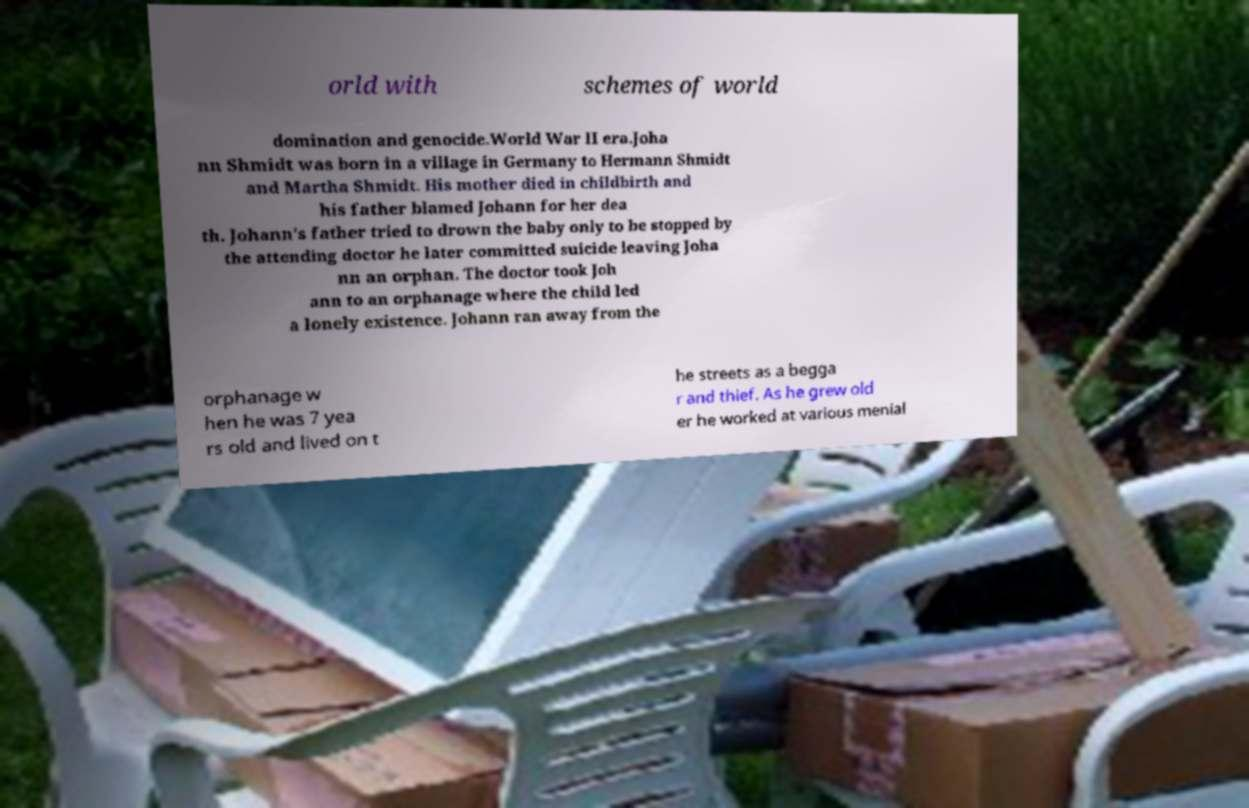What messages or text are displayed in this image? I need them in a readable, typed format. orld with schemes of world domination and genocide.World War II era.Joha nn Shmidt was born in a village in Germany to Hermann Shmidt and Martha Shmidt. His mother died in childbirth and his father blamed Johann for her dea th. Johann's father tried to drown the baby only to be stopped by the attending doctor he later committed suicide leaving Joha nn an orphan. The doctor took Joh ann to an orphanage where the child led a lonely existence. Johann ran away from the orphanage w hen he was 7 yea rs old and lived on t he streets as a begga r and thief. As he grew old er he worked at various menial 